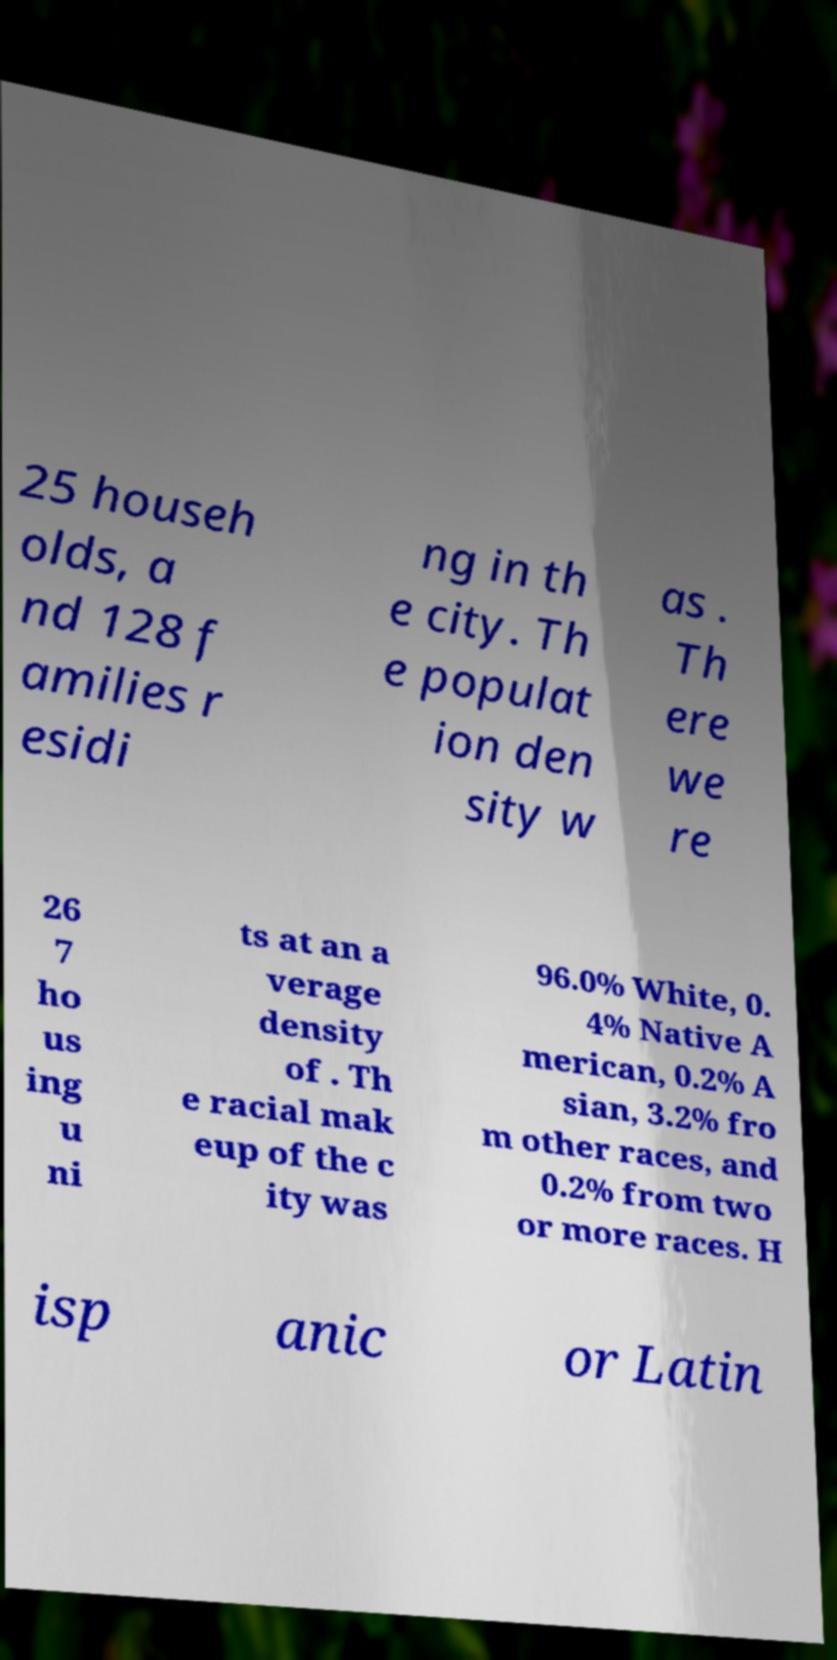What messages or text are displayed in this image? I need them in a readable, typed format. 25 househ olds, a nd 128 f amilies r esidi ng in th e city. Th e populat ion den sity w as . Th ere we re 26 7 ho us ing u ni ts at an a verage density of . Th e racial mak eup of the c ity was 96.0% White, 0. 4% Native A merican, 0.2% A sian, 3.2% fro m other races, and 0.2% from two or more races. H isp anic or Latin 